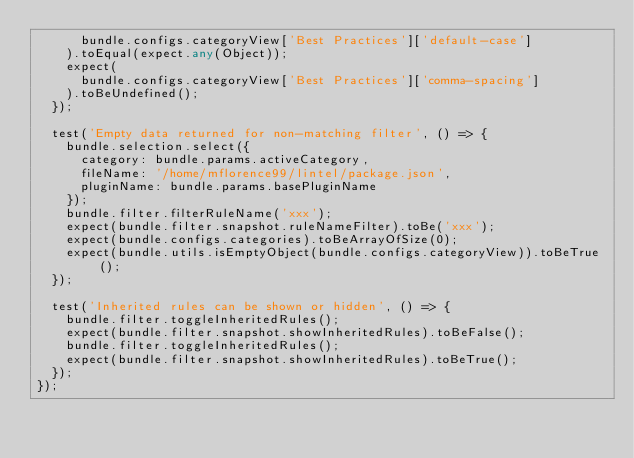<code> <loc_0><loc_0><loc_500><loc_500><_TypeScript_>      bundle.configs.categoryView['Best Practices']['default-case']
    ).toEqual(expect.any(Object));
    expect(
      bundle.configs.categoryView['Best Practices']['comma-spacing']
    ).toBeUndefined();
  });

  test('Empty data returned for non-matching filter', () => {
    bundle.selection.select({
      category: bundle.params.activeCategory,
      fileName: '/home/mflorence99/lintel/package.json',
      pluginName: bundle.params.basePluginName
    });
    bundle.filter.filterRuleName('xxx');
    expect(bundle.filter.snapshot.ruleNameFilter).toBe('xxx');
    expect(bundle.configs.categories).toBeArrayOfSize(0);
    expect(bundle.utils.isEmptyObject(bundle.configs.categoryView)).toBeTrue();
  });

  test('Inherited rules can be shown or hidden', () => {
    bundle.filter.toggleInheritedRules();
    expect(bundle.filter.snapshot.showInheritedRules).toBeFalse();
    bundle.filter.toggleInheritedRules();
    expect(bundle.filter.snapshot.showInheritedRules).toBeTrue();
  });
});
</code> 